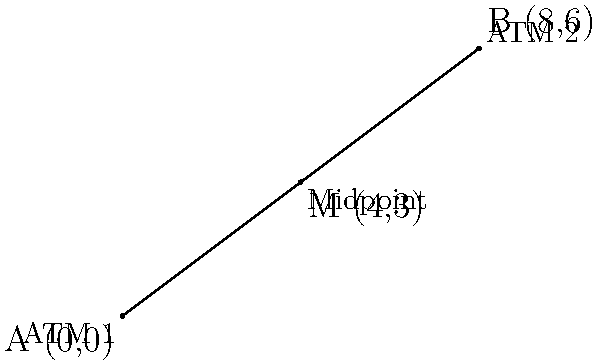Rajneesh Karnatak, as part of his banking sector initiatives, is planning to analyze the distribution of ATMs in a city. Two ATMs are located at coordinates (0,0) and (8,6). To optimize coverage, he wants to place a new ATM at the midpoint between these two locations. What are the coordinates of this new ATM location? To find the midpoint of a line segment connecting two points, we can use the midpoint formula:

$$ M_x = \frac{x_1 + x_2}{2}, \quad M_y = \frac{y_1 + y_2}{2} $$

Where $(x_1, y_1)$ and $(x_2, y_2)$ are the coordinates of the two endpoints.

Given:
- ATM 1 is at (0,0)
- ATM 2 is at (8,6)

Step 1: Calculate the x-coordinate of the midpoint:
$$ M_x = \frac{0 + 8}{2} = \frac{8}{2} = 4 $$

Step 2: Calculate the y-coordinate of the midpoint:
$$ M_y = \frac{0 + 6}{2} = \frac{6}{2} = 3 $$

Therefore, the coordinates of the new ATM location (midpoint) are (4,3).
Answer: (4,3) 